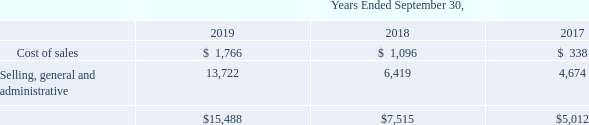We recorded non-cash compensation expense related to stock-based awards as follows (in thousands):
As of September 30, 2019, there was $39.7 million of unrecognized compensation expense related to unvested RSUs. Based upon the expected forfeitures and the expected vesting of performance-based RSUs, the aggregate fair value of RSUs expected to ultimately vest is $40.0 million, which is expected to be recognized over a weighted-average period of 1.7 years and includes the RSUs that vested on October 1, 2019.
We estimate forfeitures at the time of grant and revise those estimates in subsequent periods on a cumulative basis in the period the estimated forfeiture rate changes for all stock-based awards when significant events occur. We consider our historical experience with employee turnover as the basis to arrive at our estimated forfeiture rate. The forfeiture rate was estimated to be 12.5% per year as of September 30, 2019. To the extent the actual forfeiture rate is different from what we have estimated, compensation expense related to these awards will be different from our expectations.
What was the forfeiture rate estimated to be? 12.5% per year as of september 30, 2019. What is total non-cash compensation expense related to stock-based awards in 2019?
Answer scale should be: thousand. $15,488. For which years is the amount of non-cash compensation expense related to stock-based awards recorded? 2019, 2018, 2017. In which year was the amount of cost of sales the largest? 1,766>1,096>338
Answer: 2019. What is the change in cost of sales in 2019 from 2018?
Answer scale should be: thousand. 1,766-1,096
Answer: 670. What is the percentage change in cost of sales in 2019 from 2018?
Answer scale should be: percent. (1,766-1,096)/1,096
Answer: 61.13. 